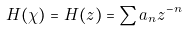<formula> <loc_0><loc_0><loc_500><loc_500>H ( \chi ) = H ( z ) = \sum a _ { n } z ^ { - n }</formula> 